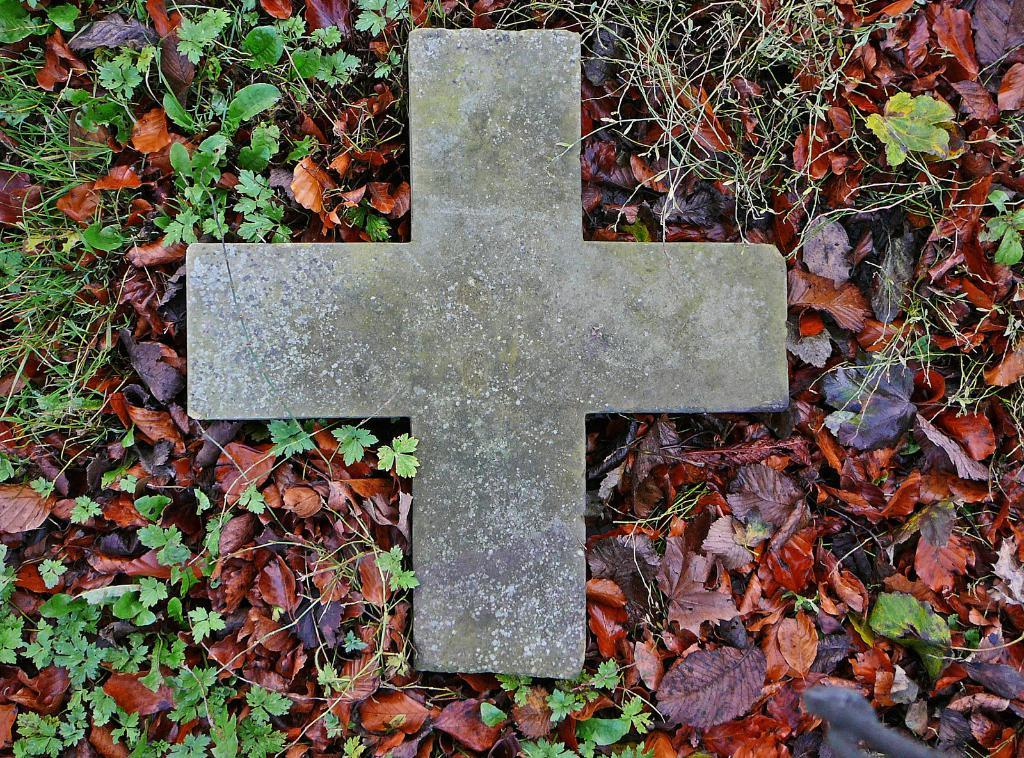What is the main subject in the center of the image? There is a stone in the shape of a cross in the center of the image. What type of vegetation can be seen at the bottom of the image? Leaves are present at the bottom of the image. What is the ground made of at the bottom of the image? Grass is visible at the bottom of the image. How many chairs are placed around the stone in the image? There are no chairs present in the image; it only features a stone in the shape of a cross, leaves, and grass. What type of furniture can be seen in the bedroom in the image? There is no bedroom or furniture present in the image. 